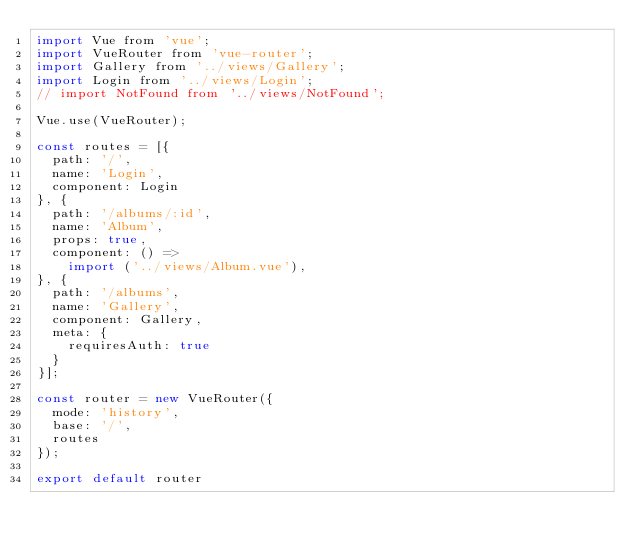<code> <loc_0><loc_0><loc_500><loc_500><_JavaScript_>import Vue from 'vue';
import VueRouter from 'vue-router';
import Gallery from '../views/Gallery';
import Login from '../views/Login';
// import NotFound from '../views/NotFound';

Vue.use(VueRouter);

const routes = [{
  path: '/',
  name: 'Login',
  component: Login
}, {
  path: '/albums/:id',
  name: 'Album',
  props: true,
  component: () =>
    import ('../views/Album.vue'),
}, {
  path: '/albums',
  name: 'Gallery',
  component: Gallery,
  meta: {
    requiresAuth: true
  }
}];

const router = new VueRouter({
  mode: 'history',
  base: '/',
  routes
});

export default router
</code> 